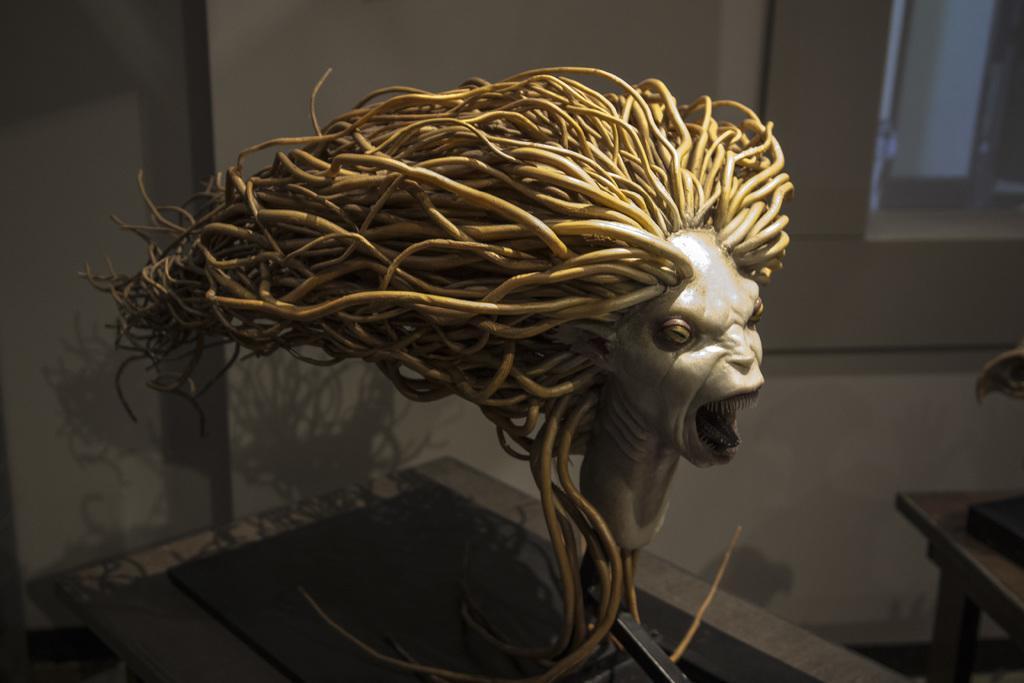How would you summarize this image in a sentence or two? In this picture we can see an idol to which there are long hairs in vertical line. 